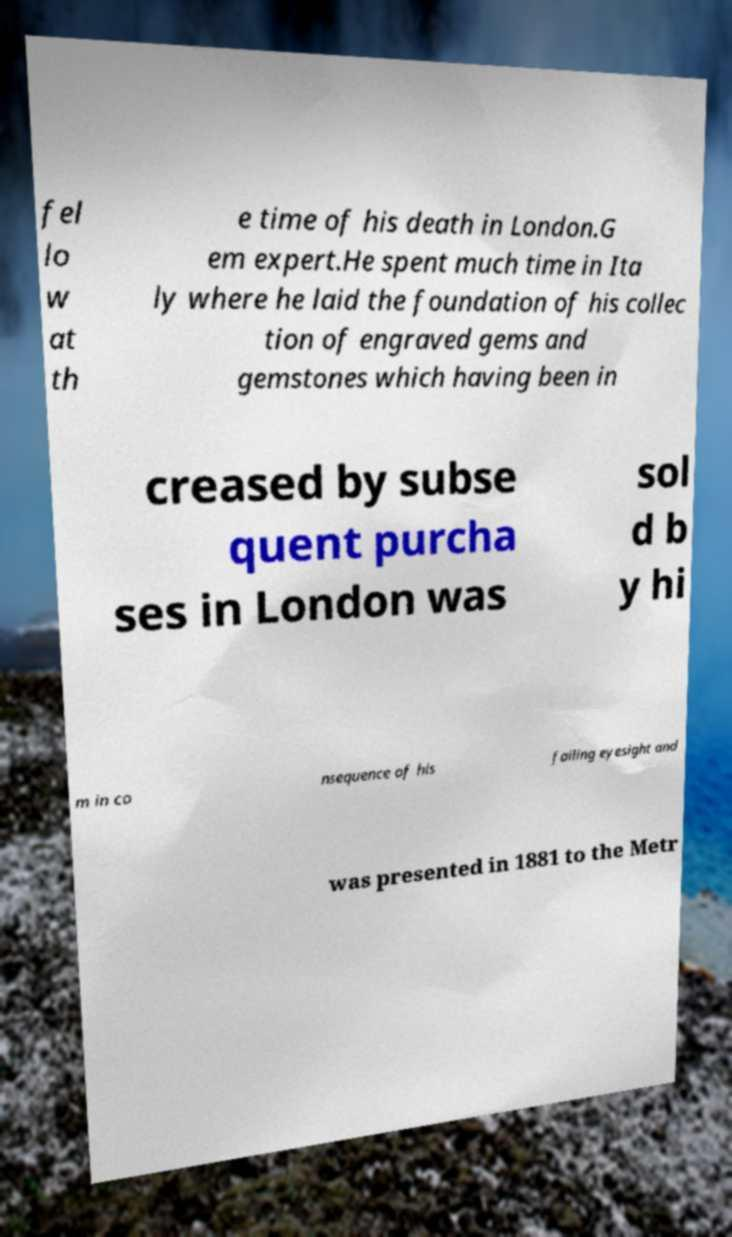I need the written content from this picture converted into text. Can you do that? fel lo w at th e time of his death in London.G em expert.He spent much time in Ita ly where he laid the foundation of his collec tion of engraved gems and gemstones which having been in creased by subse quent purcha ses in London was sol d b y hi m in co nsequence of his failing eyesight and was presented in 1881 to the Metr 